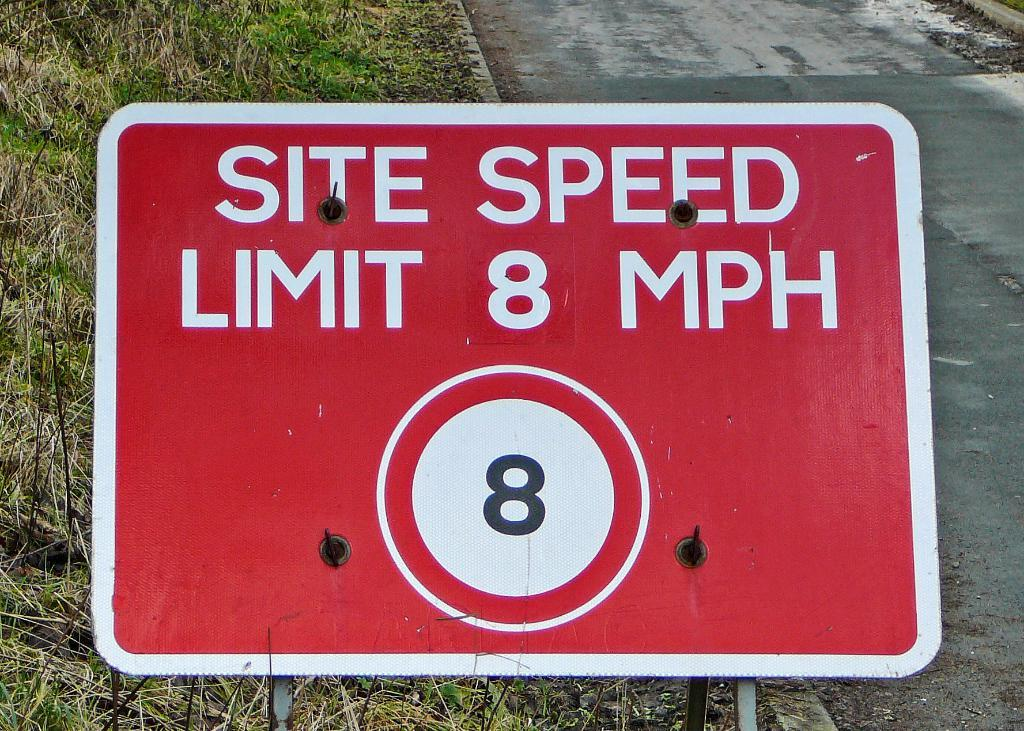<image>
Render a clear and concise summary of the photo. Road sign that says site speed limit eight mph 